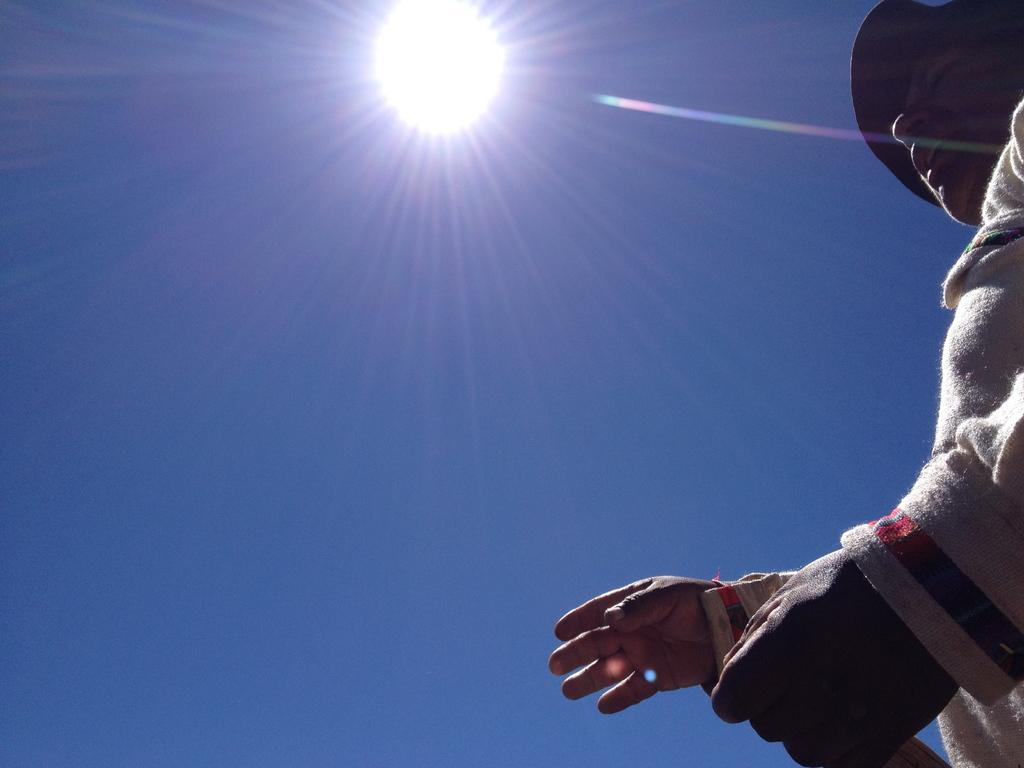Who is present in the image? There is a man in the image. What is the man wearing on his head? The man is wearing a hat. What can be seen in the sky in the image? There is a sun visible in the sky. What type of foot is visible in the image? There is no foot visible in the image; it only features a man wearing a hat and the presence of the sun in the sky. 